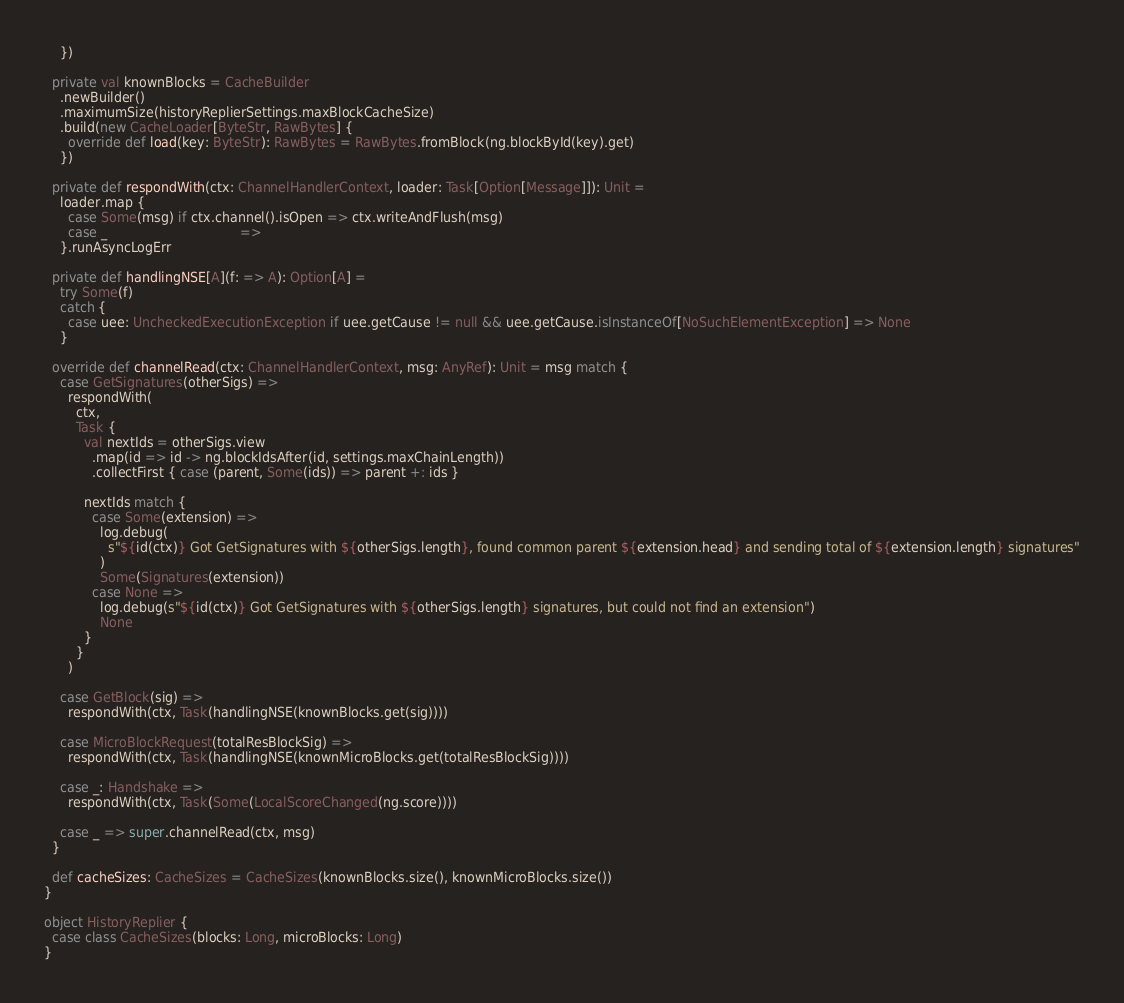<code> <loc_0><loc_0><loc_500><loc_500><_Scala_>    })

  private val knownBlocks = CacheBuilder
    .newBuilder()
    .maximumSize(historyReplierSettings.maxBlockCacheSize)
    .build(new CacheLoader[ByteStr, RawBytes] {
      override def load(key: ByteStr): RawBytes = RawBytes.fromBlock(ng.blockById(key).get)
    })

  private def respondWith(ctx: ChannelHandlerContext, loader: Task[Option[Message]]): Unit =
    loader.map {
      case Some(msg) if ctx.channel().isOpen => ctx.writeAndFlush(msg)
      case _                                 =>
    }.runAsyncLogErr

  private def handlingNSE[A](f: => A): Option[A] =
    try Some(f)
    catch {
      case uee: UncheckedExecutionException if uee.getCause != null && uee.getCause.isInstanceOf[NoSuchElementException] => None
    }

  override def channelRead(ctx: ChannelHandlerContext, msg: AnyRef): Unit = msg match {
    case GetSignatures(otherSigs) =>
      respondWith(
        ctx,
        Task {
          val nextIds = otherSigs.view
            .map(id => id -> ng.blockIdsAfter(id, settings.maxChainLength))
            .collectFirst { case (parent, Some(ids)) => parent +: ids }

          nextIds match {
            case Some(extension) =>
              log.debug(
                s"${id(ctx)} Got GetSignatures with ${otherSigs.length}, found common parent ${extension.head} and sending total of ${extension.length} signatures"
              )
              Some(Signatures(extension))
            case None =>
              log.debug(s"${id(ctx)} Got GetSignatures with ${otherSigs.length} signatures, but could not find an extension")
              None
          }
        }
      )

    case GetBlock(sig) =>
      respondWith(ctx, Task(handlingNSE(knownBlocks.get(sig))))

    case MicroBlockRequest(totalResBlockSig) =>
      respondWith(ctx, Task(handlingNSE(knownMicroBlocks.get(totalResBlockSig))))

    case _: Handshake =>
      respondWith(ctx, Task(Some(LocalScoreChanged(ng.score))))

    case _ => super.channelRead(ctx, msg)
  }

  def cacheSizes: CacheSizes = CacheSizes(knownBlocks.size(), knownMicroBlocks.size())
}

object HistoryReplier {
  case class CacheSizes(blocks: Long, microBlocks: Long)
}
</code> 